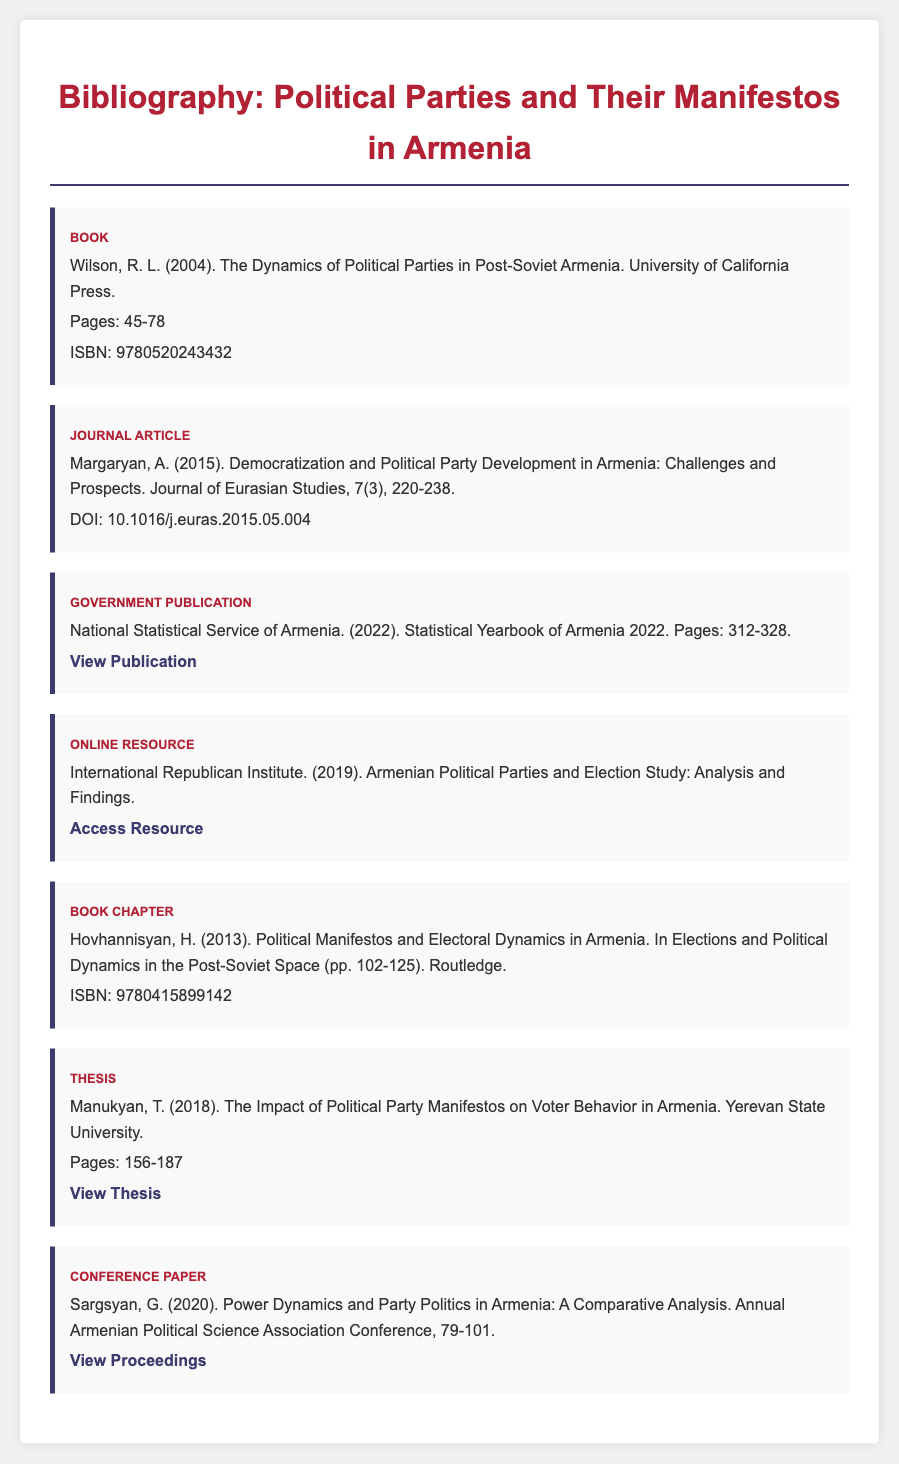what is the title of the book by Wilson? The title is found in the bibliography item for the book listed first, which is "The Dynamics of Political Parties in Post-Soviet Armenia."
Answer: The Dynamics of Political Parties in Post-Soviet Armenia who authored the journal article on democratization? This information can be found in the entry describing the journal article, specifically indicated at the start.
Answer: Margaryan, A what year was the statistical yearbook published? The publication year is stated in the government publication entry.
Answer: 2022 how many pages does the thesis by Manukyan cover? This information is provided in the thesis entry, showing the specific page range discussed.
Answer: 156-187 which organization conducted the political party and election study? The organization is mentioned in the online resource entry and can be identified at the start of the citation.
Answer: International Republican Institute how many chapters are in the book chapter by Hovhannisyan? The page range for the chapter indicates that it consists of a single chapter, typically implying one.
Answer: 1 what is the DOI for the journal article? The DOI can be found in the journal article entry, where it is explicitly mentioned by the identifier.
Answer: 10.1016/j.euras.2015.05.004 what is the ISBN for the book chapter? This information can be found within the bibliography entry for the book chapter by Hovhannisyan.
Answer: 9780415899142 what is the title of Sargsyan's conference paper? The title is provided in the entry for the conference paper, clearly stated.
Answer: Power Dynamics and Party Politics in Armenia: A Comparative Analysis 